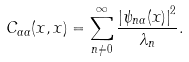Convert formula to latex. <formula><loc_0><loc_0><loc_500><loc_500>C _ { \alpha \alpha } ( x , x ) = \sum _ { n \neq 0 } ^ { \infty } \frac { \left | \psi _ { n \alpha } ( x ) \right | ^ { 2 } } { \lambda _ { n } } .</formula> 